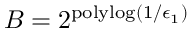<formula> <loc_0><loc_0><loc_500><loc_500>B = 2 ^ { p o l y \log ( 1 / \epsilon _ { 1 } ) }</formula> 